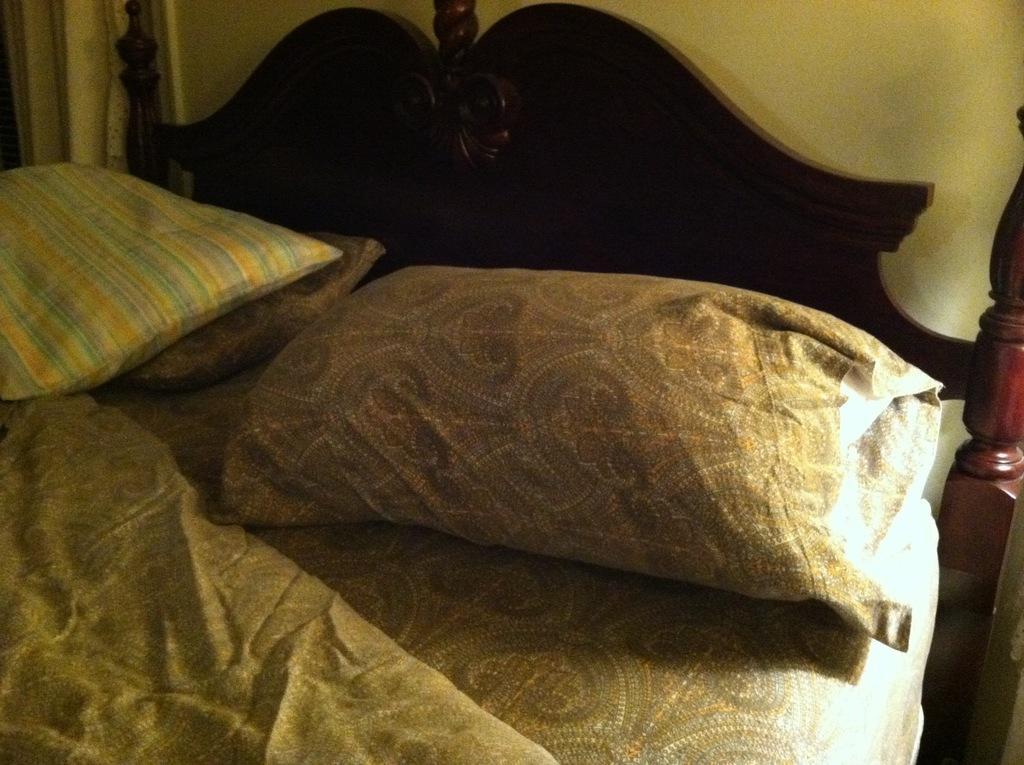Could you give a brief overview of what you see in this image? In this image I can see a bed. On this bed there are few pillows. 